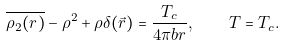Convert formula to latex. <formula><loc_0><loc_0><loc_500><loc_500>\overline { \rho _ { 2 } ( r ) } - \rho ^ { 2 } + \rho \delta ( \vec { r } ) = \frac { T _ { c } } { 4 \pi b r } , \quad T = T _ { c } .</formula> 